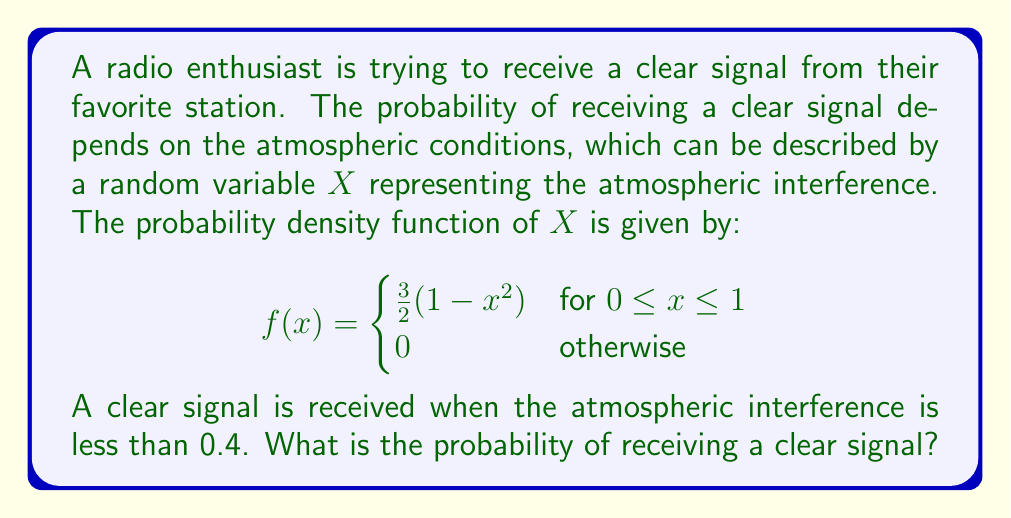Show me your answer to this math problem. To solve this problem, we need to find the probability that $X$ is less than 0.4. This can be done by integrating the probability density function from 0 to 0.4.

The probability is given by:

$$P(X < 0.4) = \int_0^{0.4} f(x) dx$$

Substituting the given probability density function:

$$P(X < 0.4) = \int_0^{0.4} \frac{3}{2}(1-x^2) dx$$

Now, let's solve this integral:

$$\begin{align}
P(X < 0.4) &= \frac{3}{2} \int_0^{0.4} (1-x^2) dx \\
&= \frac{3}{2} \left[x - \frac{x^3}{3}\right]_0^{0.4} \\
&= \frac{3}{2} \left[(0.4 - \frac{0.4^3}{3}) - (0 - 0)\right] \\
&= \frac{3}{2} \left(0.4 - \frac{0.064}{3}\right) \\
&= \frac{3}{2} (0.4 - 0.02133...) \\
&= \frac{3}{2} (0.37866...) \\
&= 0.568
\end{align}$$

Therefore, the probability of receiving a clear signal is approximately 0.568 or 56.8%.
Answer: $0.568$ or $56.8\%$ 